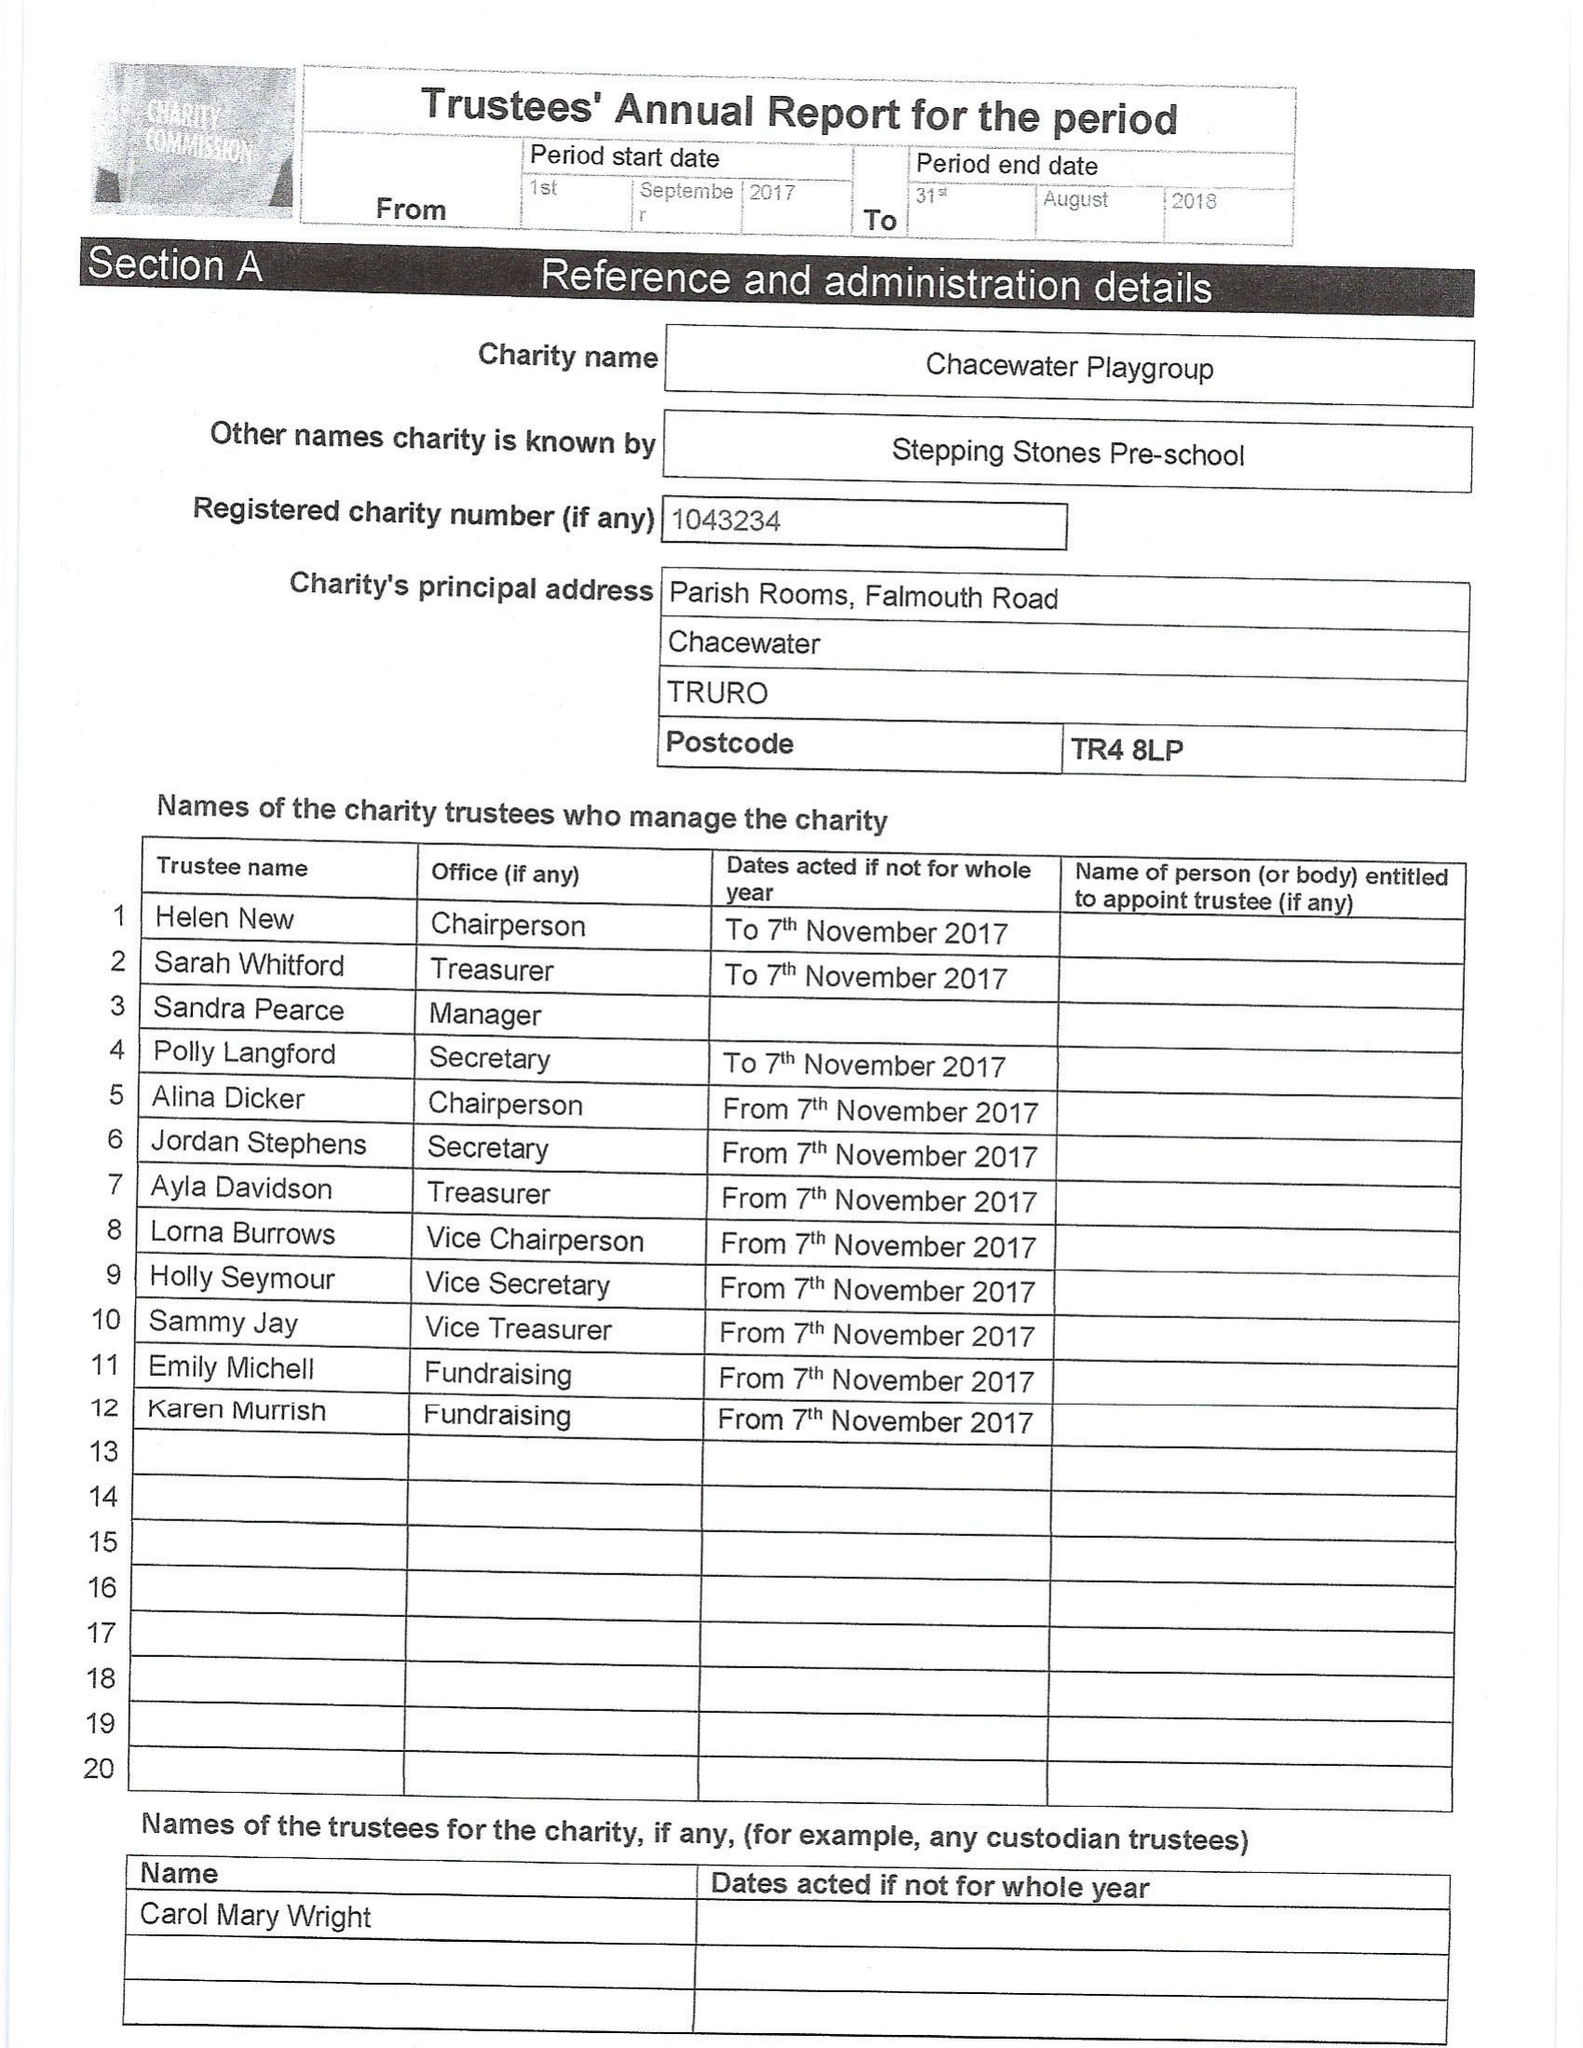What is the value for the charity_number?
Answer the question using a single word or phrase. 1043234 